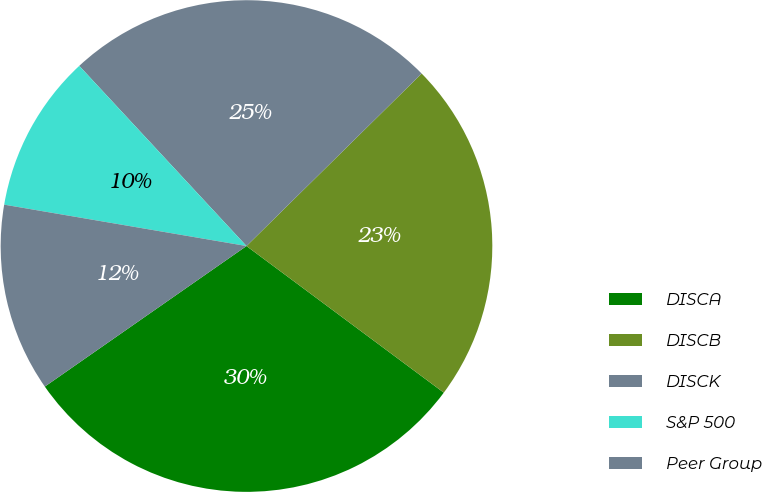Convert chart to OTSL. <chart><loc_0><loc_0><loc_500><loc_500><pie_chart><fcel>DISCA<fcel>DISCB<fcel>DISCK<fcel>S&P 500<fcel>Peer Group<nl><fcel>30.14%<fcel>22.55%<fcel>24.53%<fcel>10.4%<fcel>12.38%<nl></chart> 